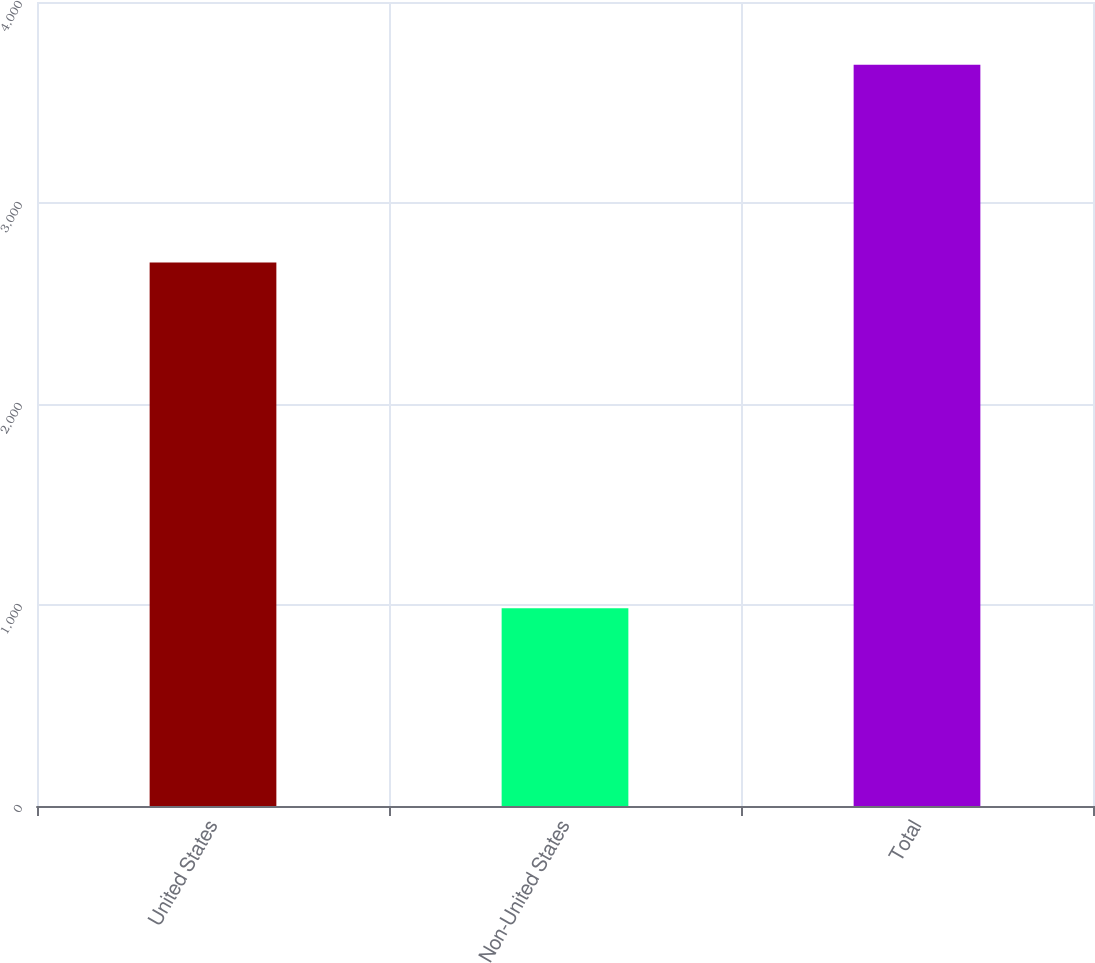Convert chart to OTSL. <chart><loc_0><loc_0><loc_500><loc_500><bar_chart><fcel>United States<fcel>Non-United States<fcel>Total<nl><fcel>2704<fcel>983.7<fcel>3687.7<nl></chart> 